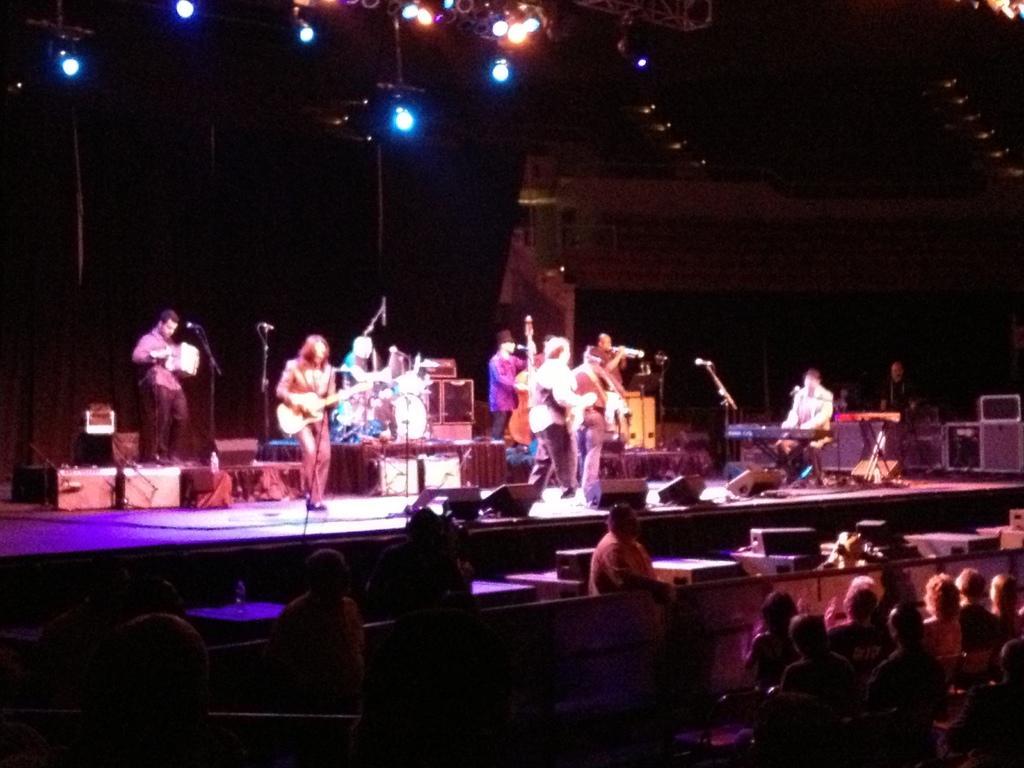Please provide a concise description of this image. These persons are standing. This person holding guitar. There is microphones with stand. These are audience. This person standing. This person sitting and playing musical instrument. 